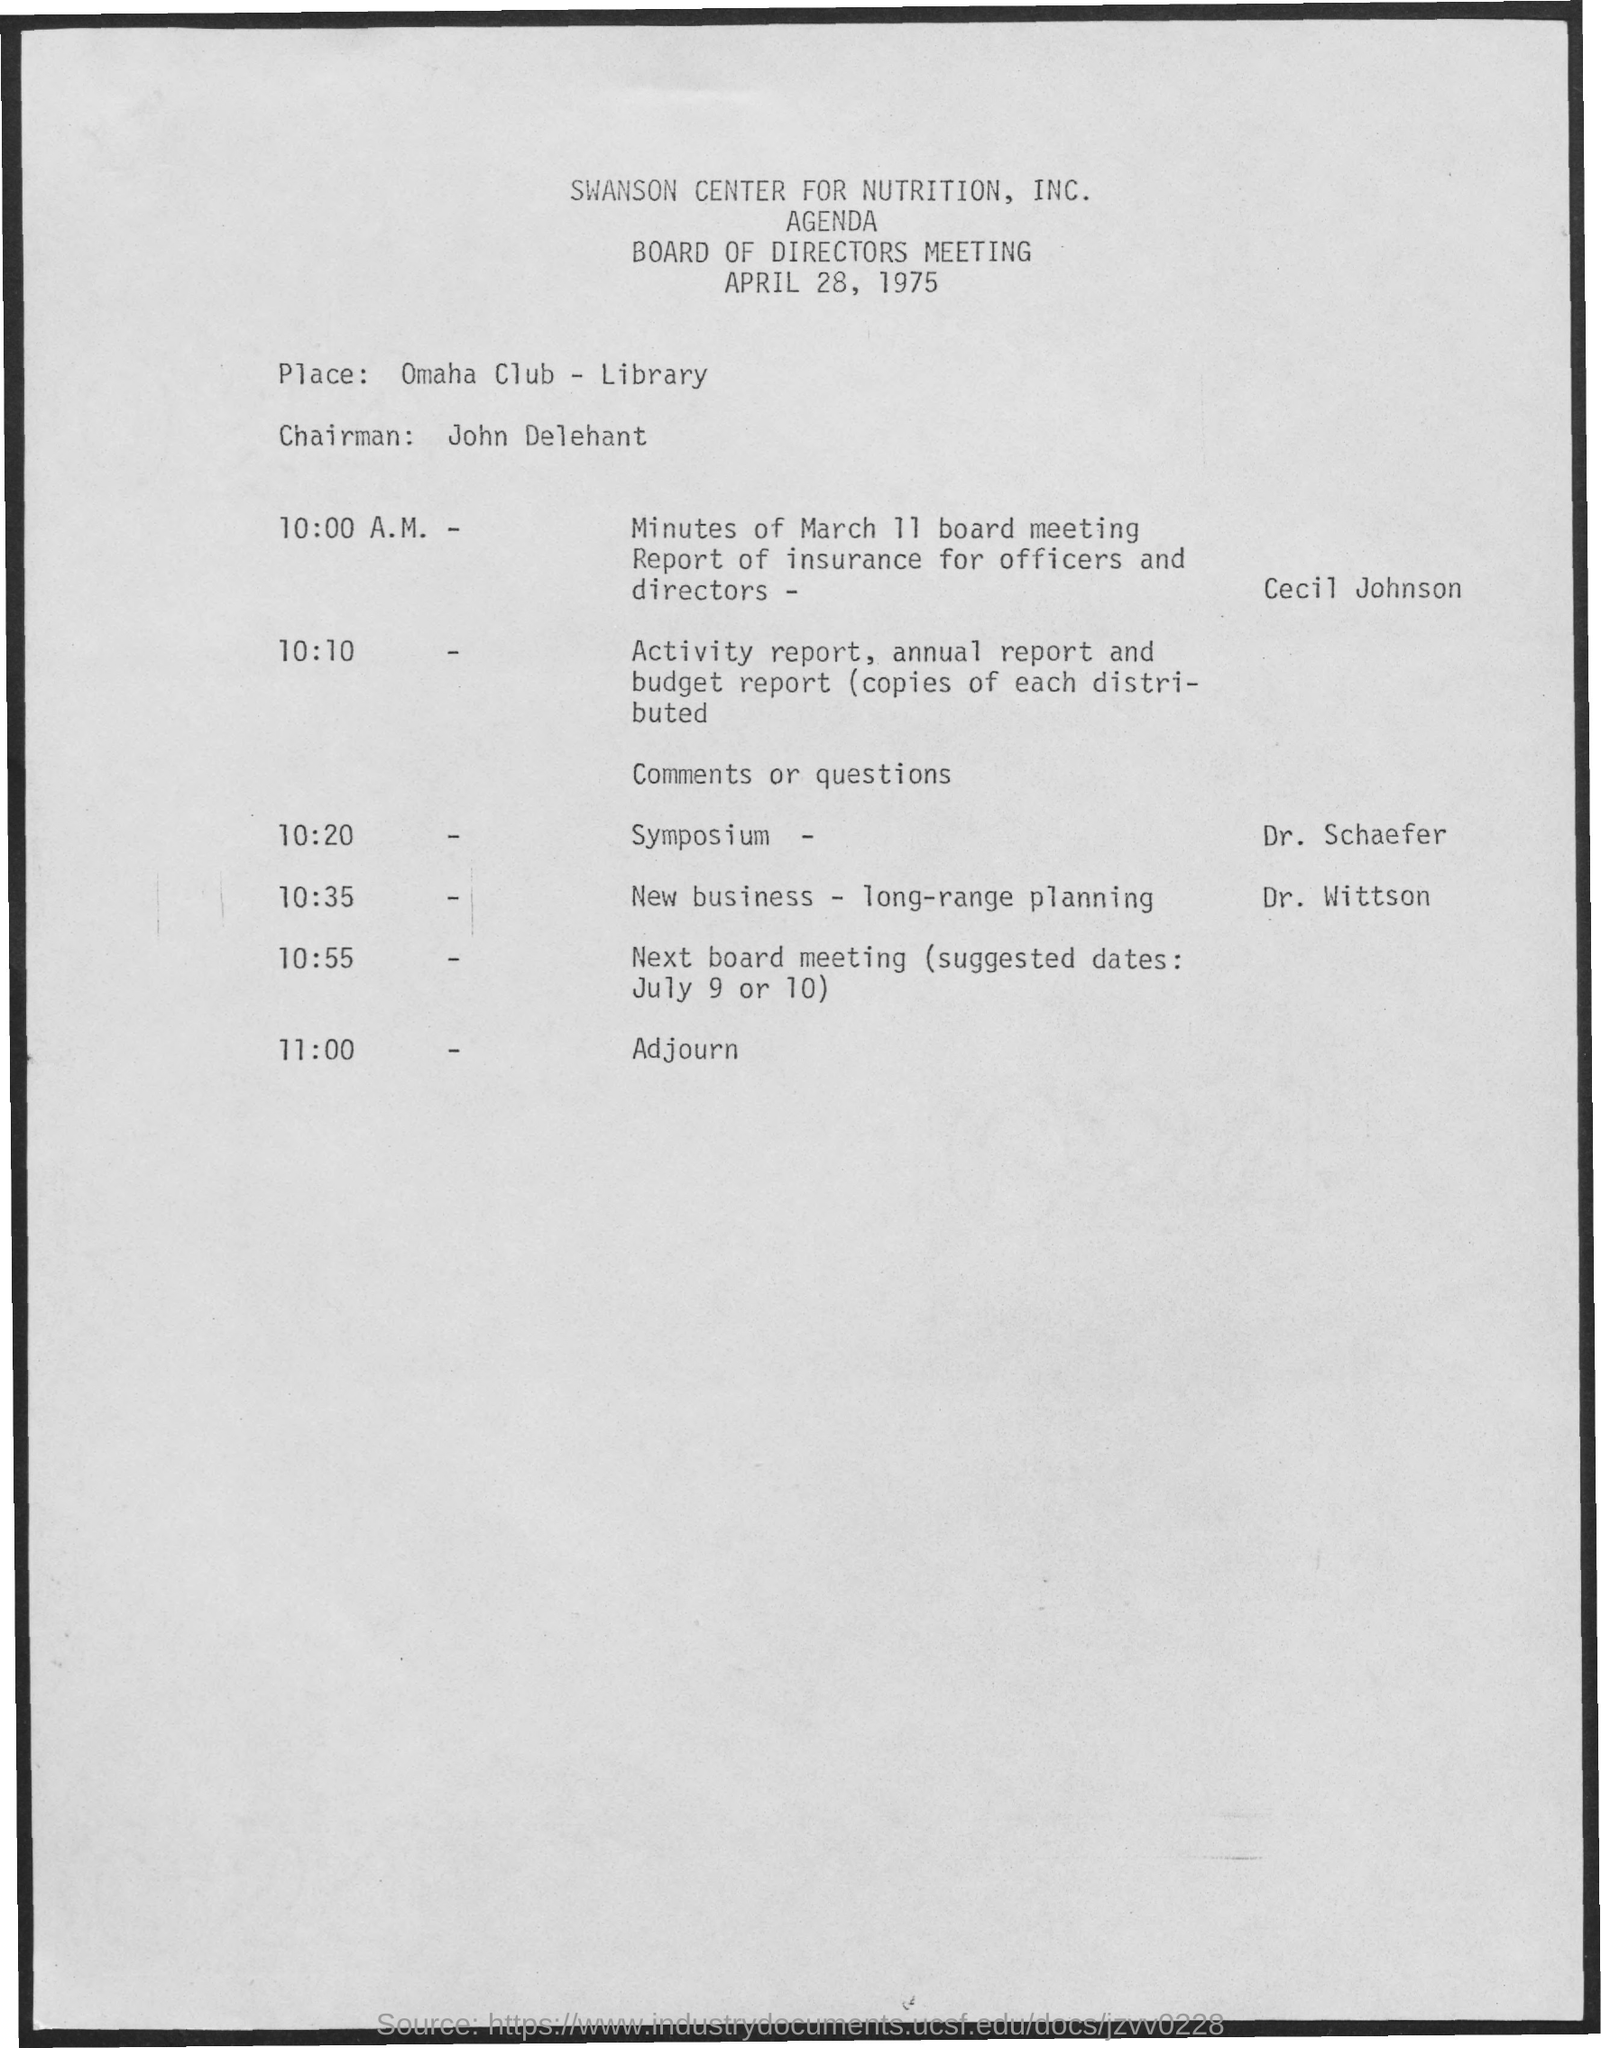Draw attention to some important aspects in this diagram. The symposium is being presented by Dr. Schaefer. The Omaha Club library is the place. The time for adjournment has been set for 11:00... The new business long-range planning will occur at 10:35. The meeting is scheduled for April 28, 1975. 